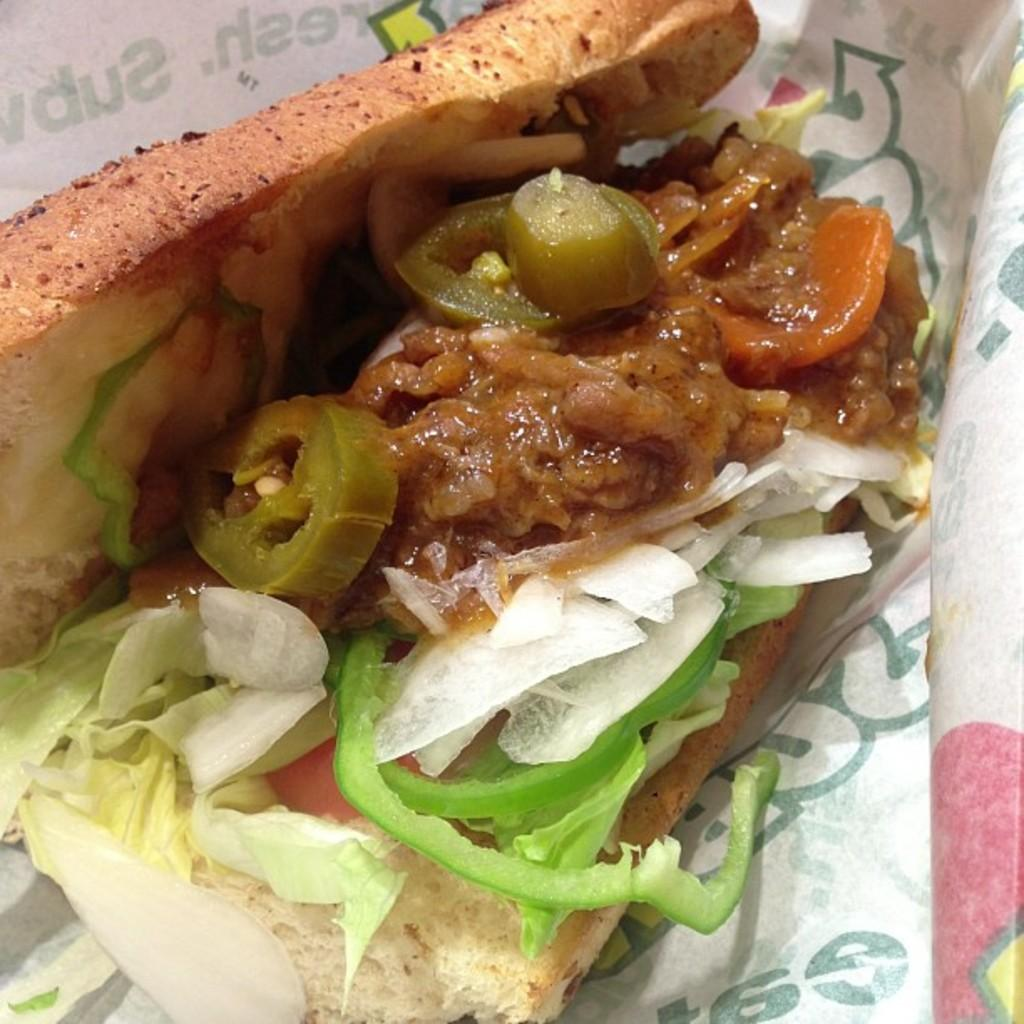What is the main subject in the center of the image? There is food in the center of the image. What else can be seen in the image besides the food? There is a white-colored paper in the image. Is there any text or drawing on the paper? Yes, something is written on the paper. What type of card can be seen in the cemetery in the image? There is no cemetery or card present in the image; it features food and a white-colored paper with writing on it. 